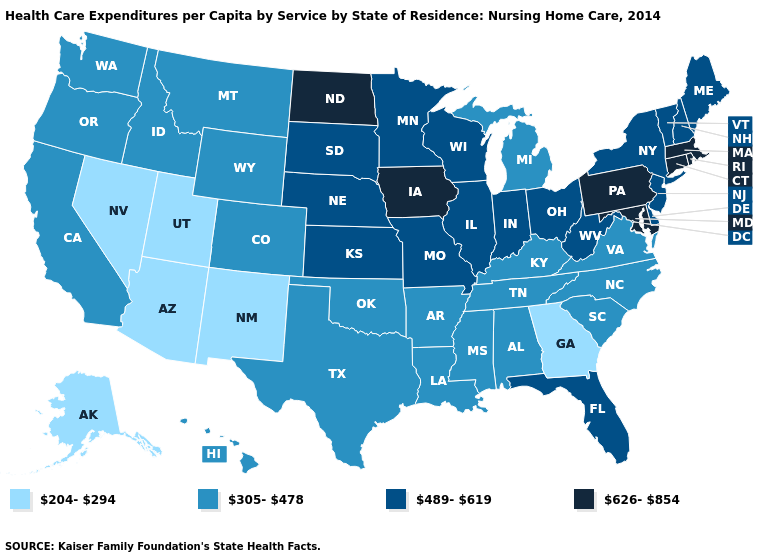Does the map have missing data?
Keep it brief. No. Does Pennsylvania have the highest value in the USA?
Keep it brief. Yes. What is the highest value in the USA?
Be succinct. 626-854. What is the value of Vermont?
Short answer required. 489-619. What is the lowest value in the MidWest?
Give a very brief answer. 305-478. What is the lowest value in the USA?
Write a very short answer. 204-294. What is the highest value in the USA?
Write a very short answer. 626-854. What is the lowest value in the USA?
Answer briefly. 204-294. What is the lowest value in states that border Washington?
Give a very brief answer. 305-478. Which states hav the highest value in the South?
Answer briefly. Maryland. What is the value of Georgia?
Give a very brief answer. 204-294. Name the states that have a value in the range 305-478?
Concise answer only. Alabama, Arkansas, California, Colorado, Hawaii, Idaho, Kentucky, Louisiana, Michigan, Mississippi, Montana, North Carolina, Oklahoma, Oregon, South Carolina, Tennessee, Texas, Virginia, Washington, Wyoming. Does Arizona have a lower value than Michigan?
Keep it brief. Yes. Name the states that have a value in the range 626-854?
Concise answer only. Connecticut, Iowa, Maryland, Massachusetts, North Dakota, Pennsylvania, Rhode Island. How many symbols are there in the legend?
Keep it brief. 4. 